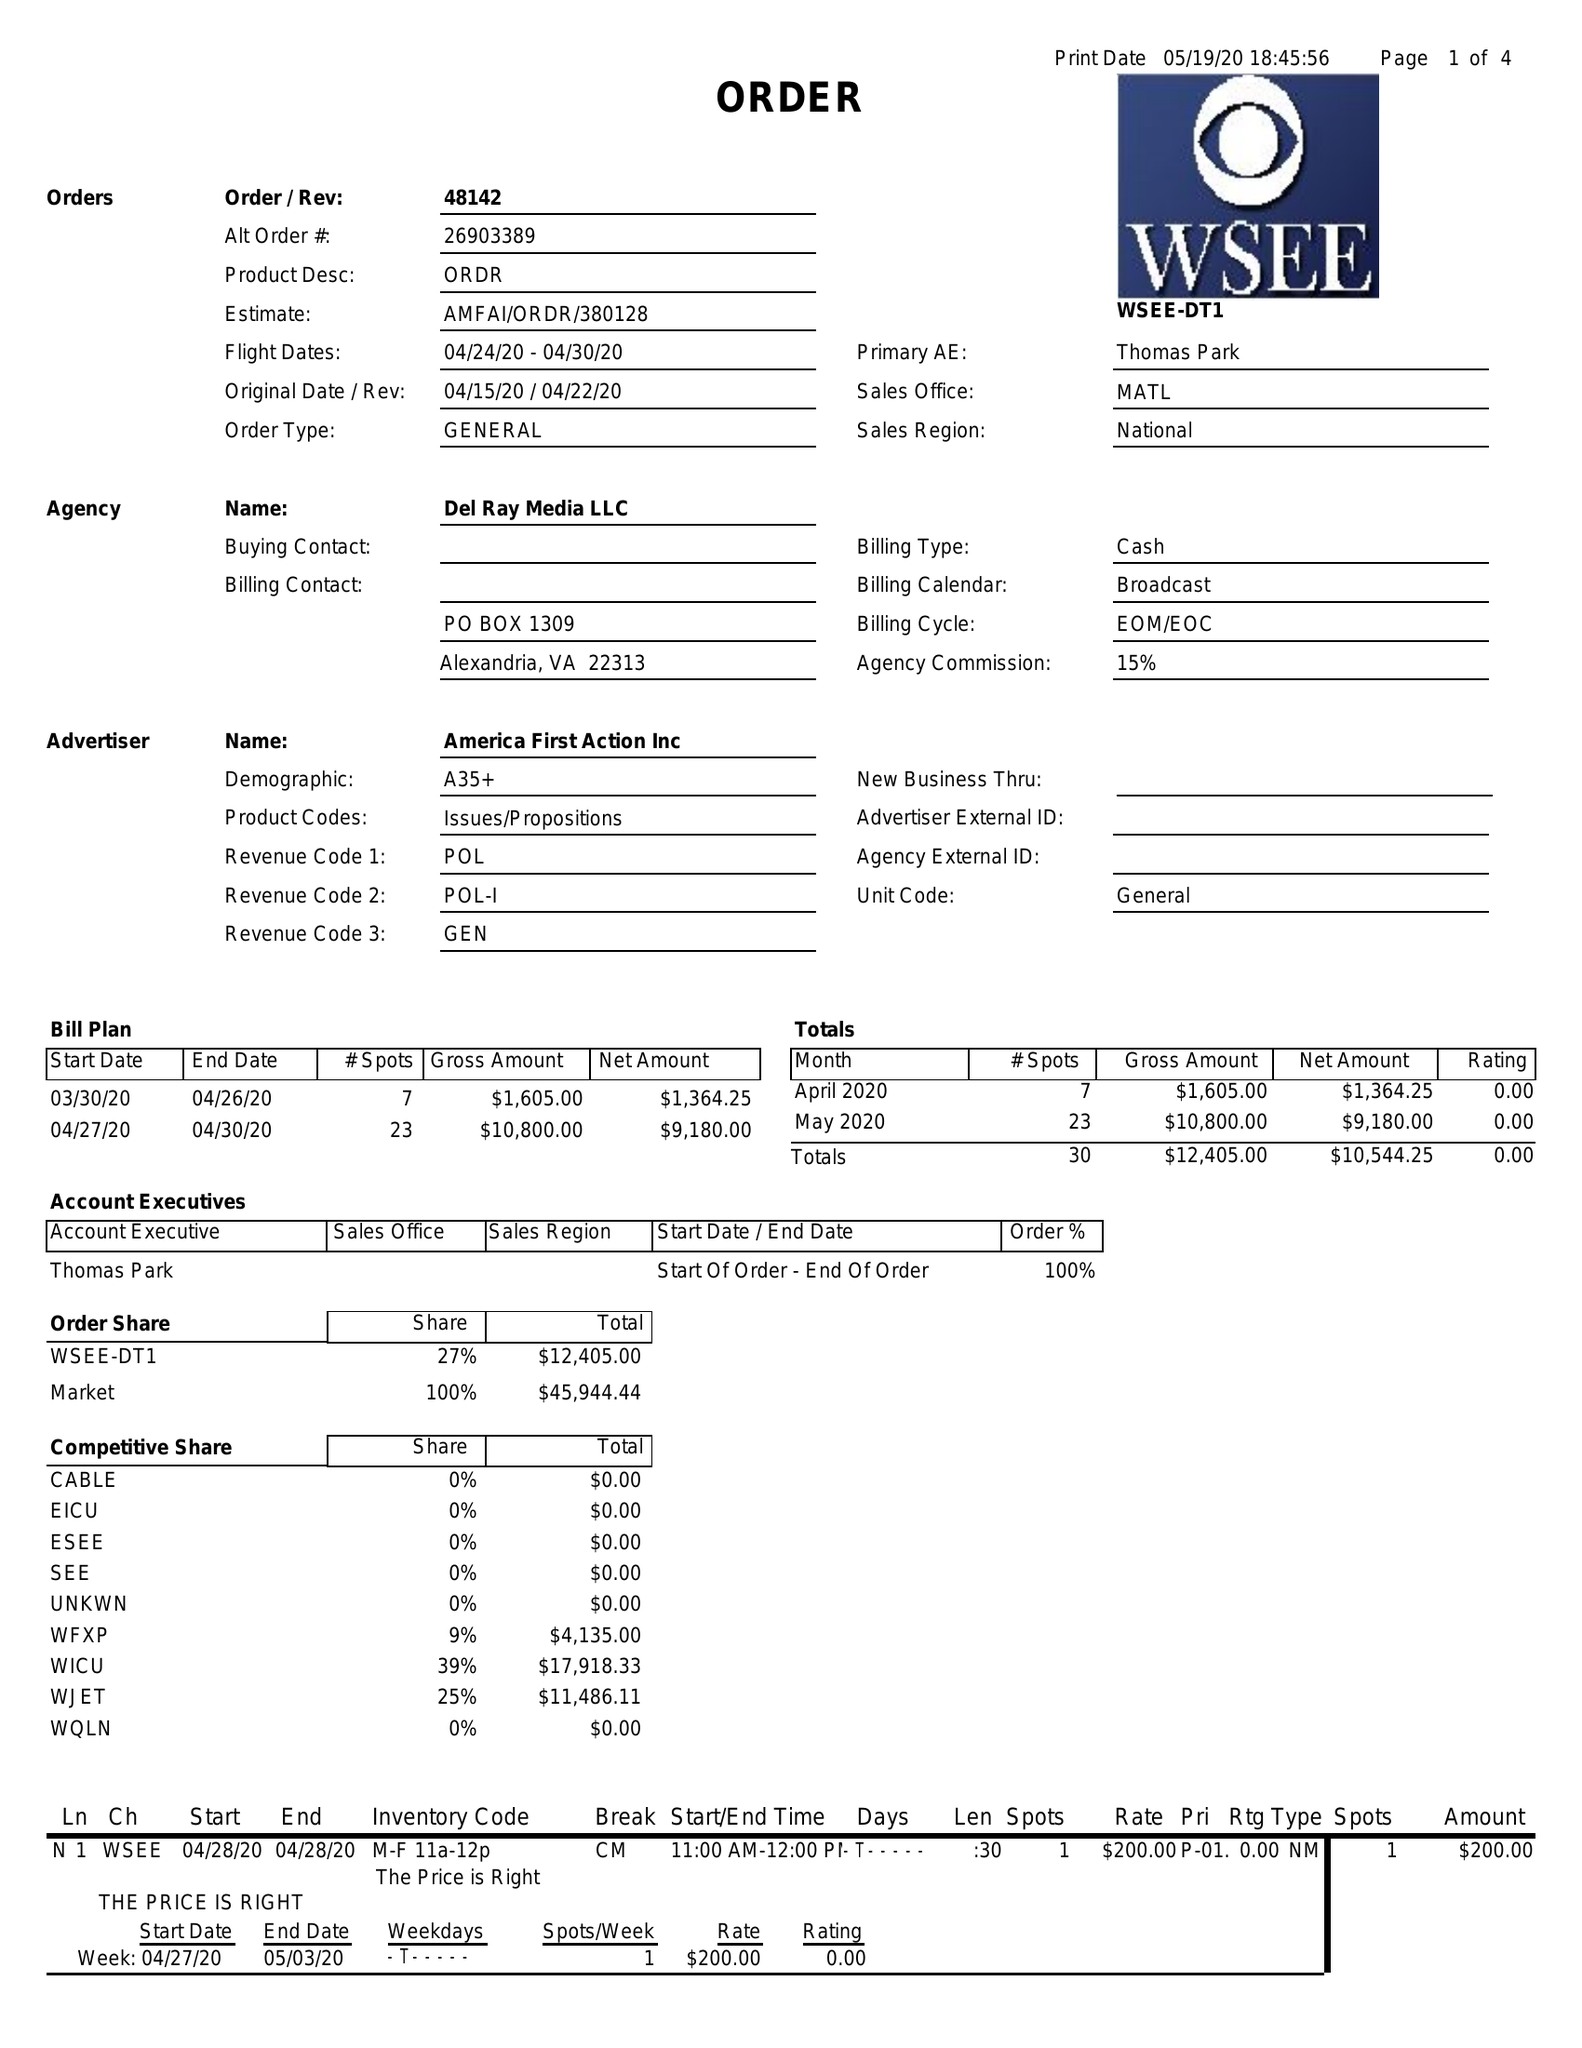What is the value for the gross_amount?
Answer the question using a single word or phrase. 12405.00 